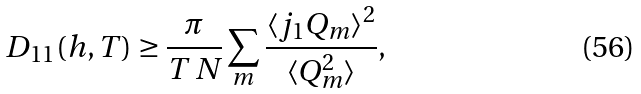<formula> <loc_0><loc_0><loc_500><loc_500>D _ { 1 1 } ( h , T ) \geq \frac { \pi } { T \, N } \sum _ { m } \frac { \langle j _ { 1 } Q _ { m } \rangle ^ { 2 } } { \langle Q _ { m } ^ { 2 } \rangle } ,</formula> 